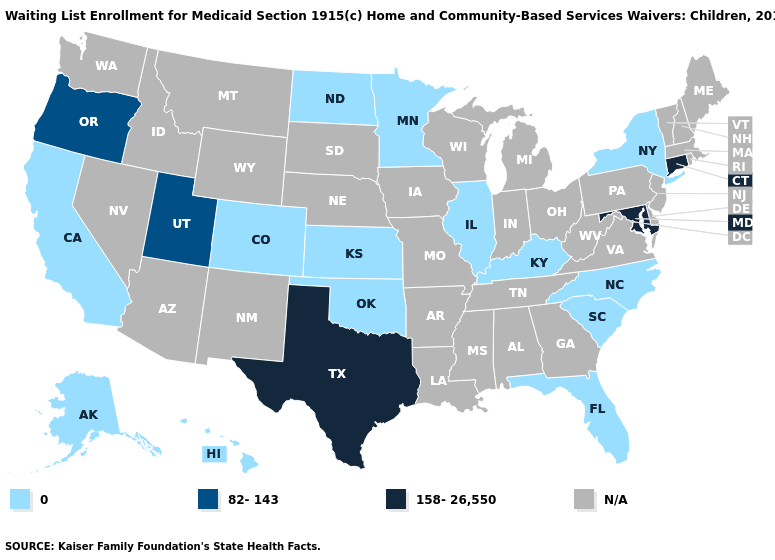Which states have the lowest value in the USA?
Be succinct. Alaska, California, Colorado, Florida, Hawaii, Illinois, Kansas, Kentucky, Minnesota, New York, North Carolina, North Dakota, Oklahoma, South Carolina. Name the states that have a value in the range 158-26,550?
Quick response, please. Connecticut, Maryland, Texas. Name the states that have a value in the range N/A?
Give a very brief answer. Alabama, Arizona, Arkansas, Delaware, Georgia, Idaho, Indiana, Iowa, Louisiana, Maine, Massachusetts, Michigan, Mississippi, Missouri, Montana, Nebraska, Nevada, New Hampshire, New Jersey, New Mexico, Ohio, Pennsylvania, Rhode Island, South Dakota, Tennessee, Vermont, Virginia, Washington, West Virginia, Wisconsin, Wyoming. Which states have the lowest value in the USA?
Keep it brief. Alaska, California, Colorado, Florida, Hawaii, Illinois, Kansas, Kentucky, Minnesota, New York, North Carolina, North Dakota, Oklahoma, South Carolina. Name the states that have a value in the range 82-143?
Answer briefly. Oregon, Utah. Does the map have missing data?
Short answer required. Yes. What is the highest value in the South ?
Quick response, please. 158-26,550. What is the value of Tennessee?
Write a very short answer. N/A. Name the states that have a value in the range 158-26,550?
Short answer required. Connecticut, Maryland, Texas. Name the states that have a value in the range 0?
Short answer required. Alaska, California, Colorado, Florida, Hawaii, Illinois, Kansas, Kentucky, Minnesota, New York, North Carolina, North Dakota, Oklahoma, South Carolina. Name the states that have a value in the range 0?
Give a very brief answer. Alaska, California, Colorado, Florida, Hawaii, Illinois, Kansas, Kentucky, Minnesota, New York, North Carolina, North Dakota, Oklahoma, South Carolina. Does Connecticut have the highest value in the USA?
Concise answer only. Yes. 